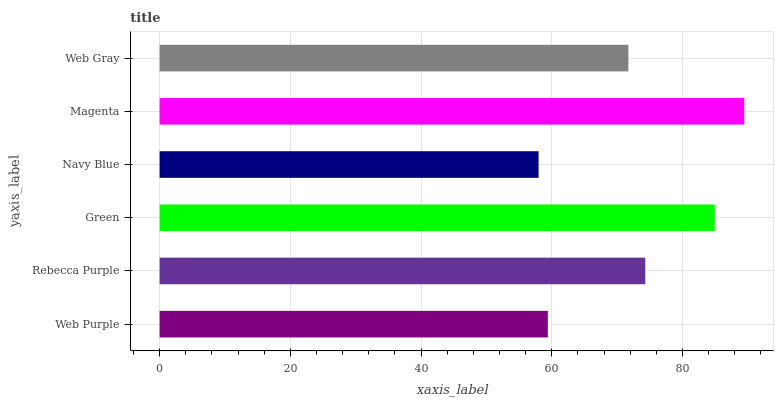Is Navy Blue the minimum?
Answer yes or no. Yes. Is Magenta the maximum?
Answer yes or no. Yes. Is Rebecca Purple the minimum?
Answer yes or no. No. Is Rebecca Purple the maximum?
Answer yes or no. No. Is Rebecca Purple greater than Web Purple?
Answer yes or no. Yes. Is Web Purple less than Rebecca Purple?
Answer yes or no. Yes. Is Web Purple greater than Rebecca Purple?
Answer yes or no. No. Is Rebecca Purple less than Web Purple?
Answer yes or no. No. Is Rebecca Purple the high median?
Answer yes or no. Yes. Is Web Gray the low median?
Answer yes or no. Yes. Is Magenta the high median?
Answer yes or no. No. Is Rebecca Purple the low median?
Answer yes or no. No. 